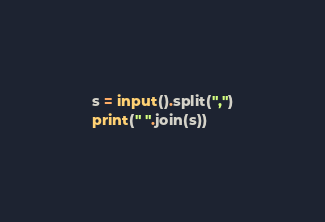<code> <loc_0><loc_0><loc_500><loc_500><_Python_>s = input().split(",")
print(" ".join(s))</code> 